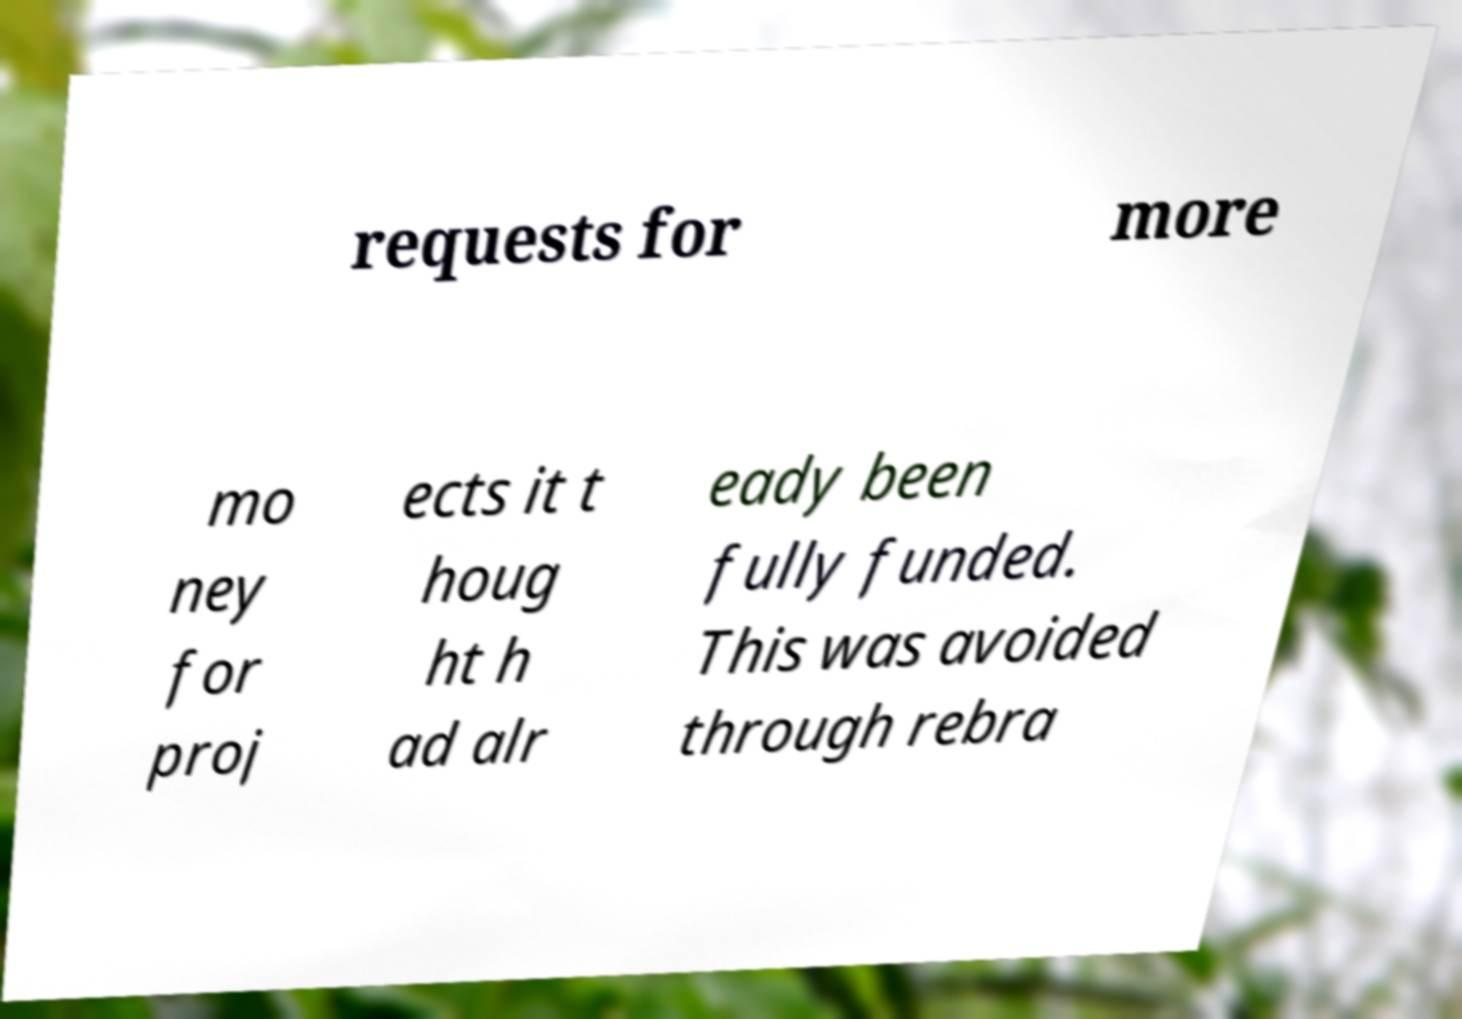Please identify and transcribe the text found in this image. requests for more mo ney for proj ects it t houg ht h ad alr eady been fully funded. This was avoided through rebra 